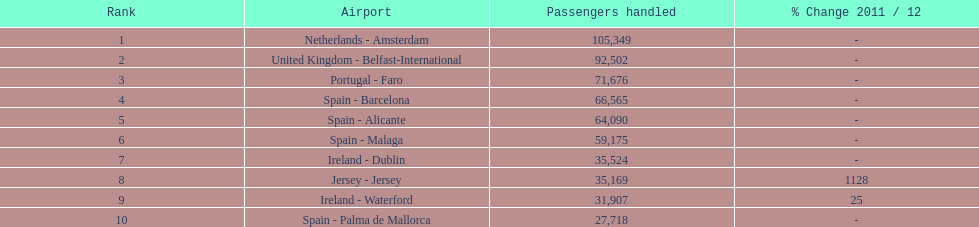How many travelers were managed at an airport in spain? 217,548. 